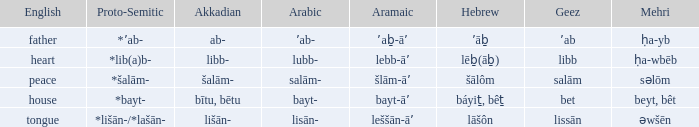If in arabic it is salām-, what is it in proto-semitic? *šalām-. 